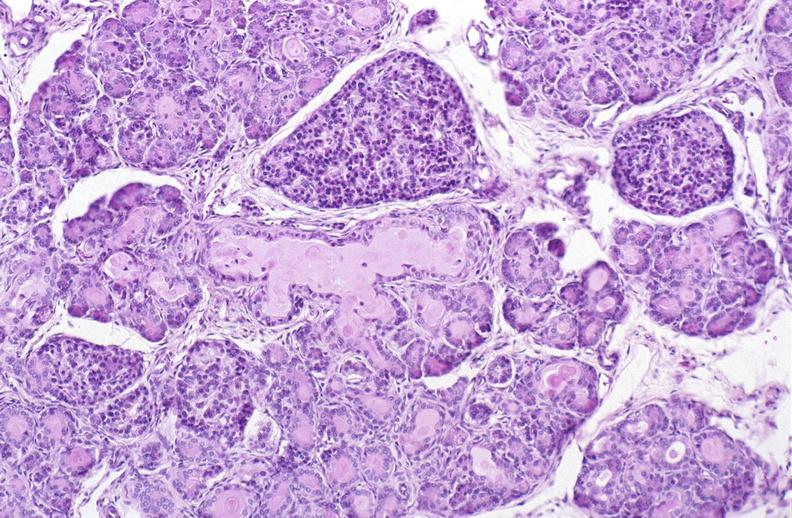what is present?
Answer the question using a single word or phrase. Pancreas 